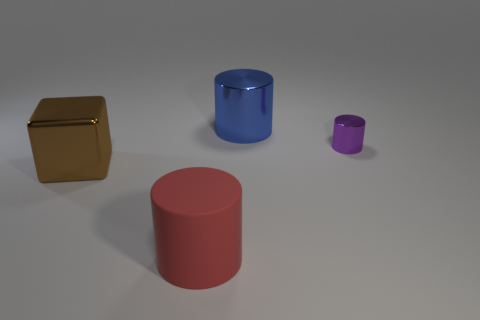Add 3 blue metallic objects. How many objects exist? 7 Subtract all big metal cylinders. How many cylinders are left? 2 Subtract all cylinders. How many objects are left? 1 Subtract all purple cylinders. How many cylinders are left? 2 Subtract 1 cylinders. How many cylinders are left? 2 Subtract all purple blocks. Subtract all gray cylinders. How many blocks are left? 1 Subtract all yellow blocks. How many red cylinders are left? 1 Subtract all large rubber cylinders. Subtract all cyan blocks. How many objects are left? 3 Add 1 large cylinders. How many large cylinders are left? 3 Add 2 big blue metal things. How many big blue metal things exist? 3 